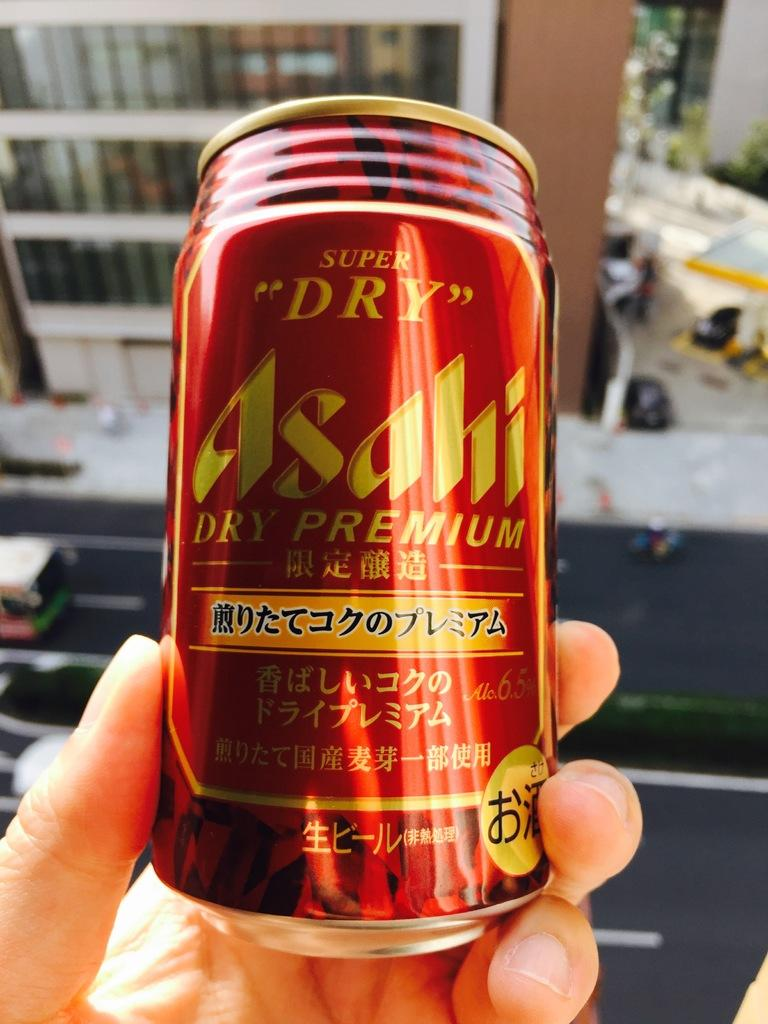<image>
Render a clear and concise summary of the photo. A hand holding a red drink can that has a foreign language on it but says Super Dry on it in English. 